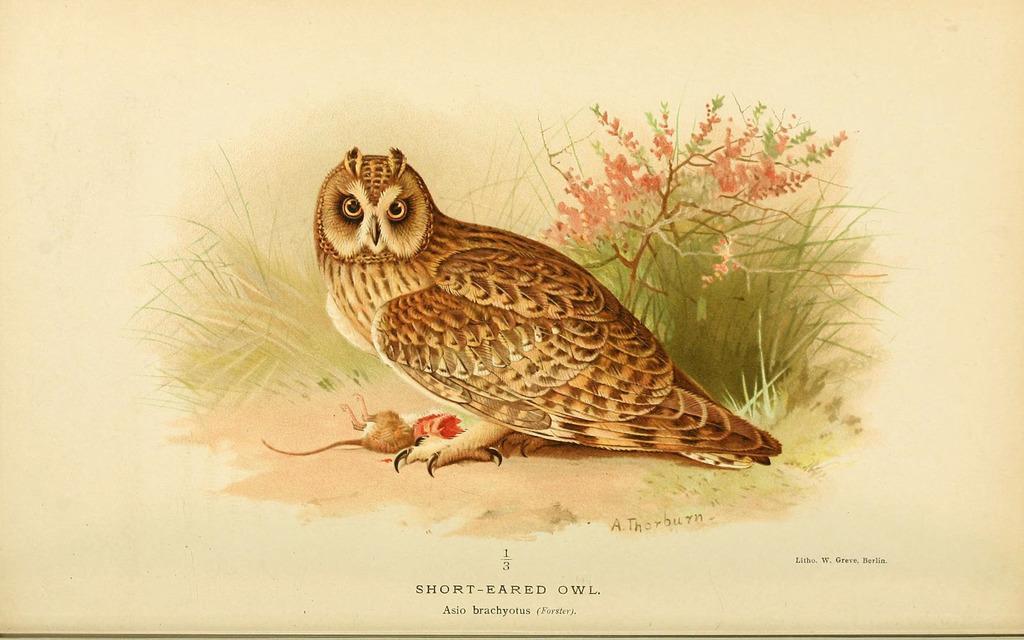Can you describe this image briefly? Here we can see a paper, in this paper we can see painting of an owl, grass and flowers. 